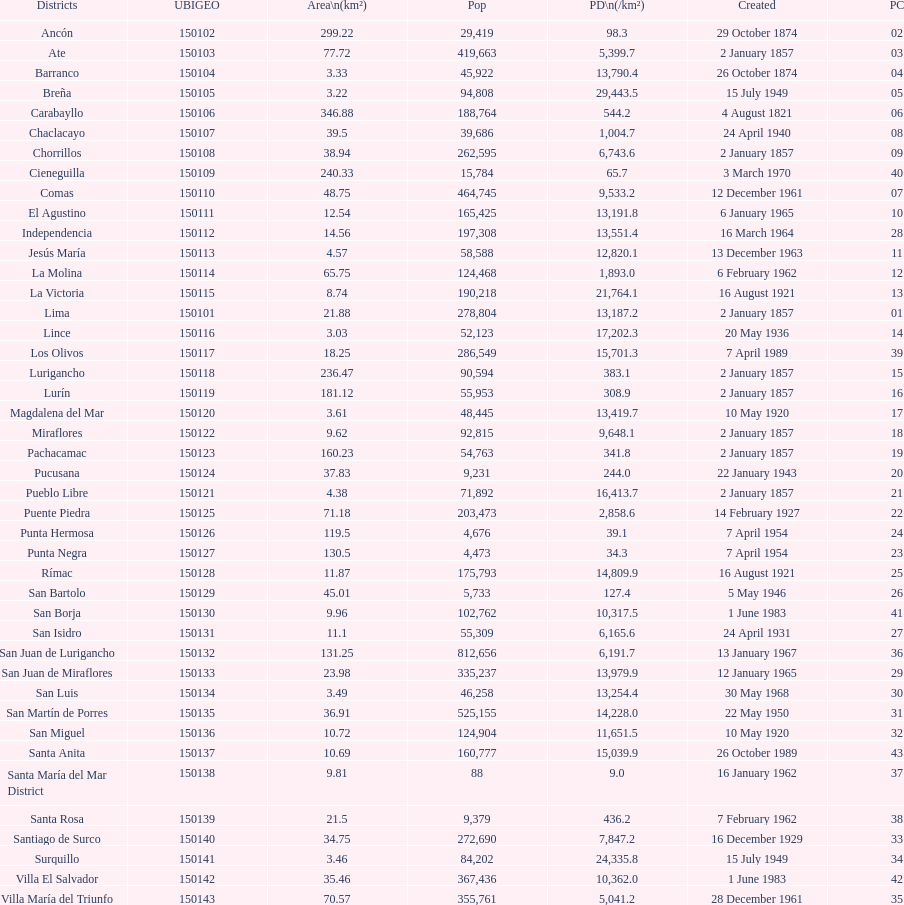Which district in this city has the greatest population? San Juan de Lurigancho. 